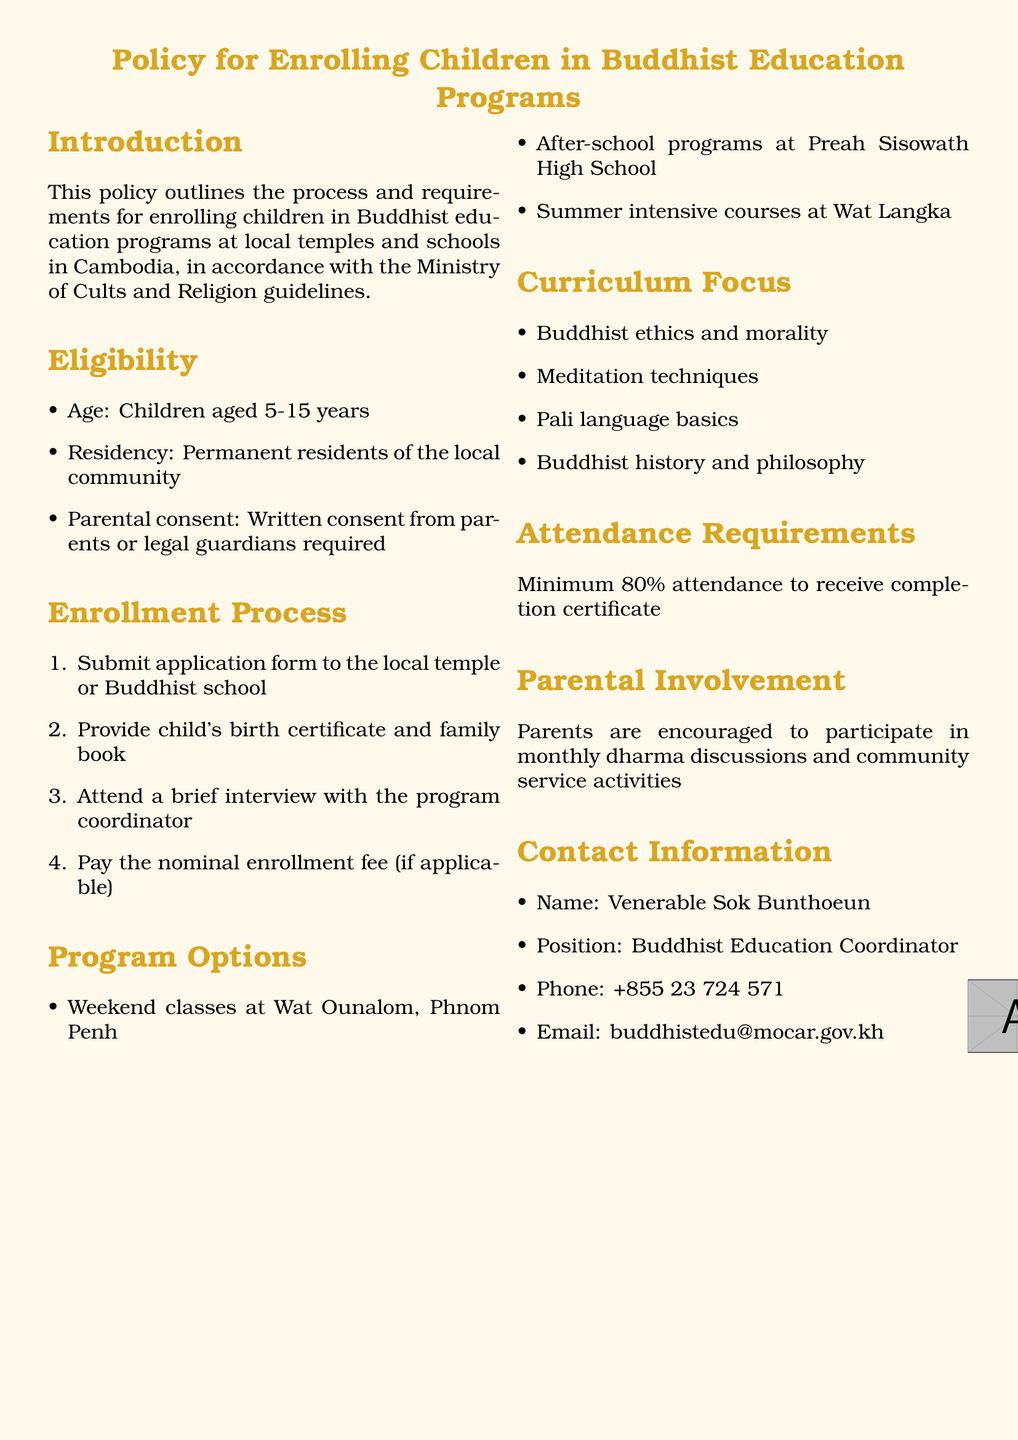What is the age range for eligibility? The eligibility age range is specified in the document.
Answer: 5-15 years Who is the Buddhist Education Coordinator? The document provides the name of the coordinator responsible for the educational programs.
Answer: Venerable Sok Bunthoeun What is the minimum attendance requirement? The document states the minimum percentage required for attendance to receive a certificate.
Answer: 80% What is required for parental consent? The document mentions what is needed from parents or guardians for enrollment.
Answer: Written consent What classes are offered at Wat Ounalom? The document lists program options available at a specific temple.
Answer: Weekend classes What type of involvement is encouraged for parents? The document specifies the type of engagement encouraged for parents in the program.
Answer: Monthly dharma discussions How many steps are in the enrollment process? The document outlines the number of sequential steps children must follow to enroll.
Answer: Four What is required alongside the application form? The document indicates documentation that must accompany the application.
Answer: Child's birth certificate and family book What are the summer course locations mentioned? The document highlights specific locations offering summer-intensive courses.
Answer: Wat Langka 